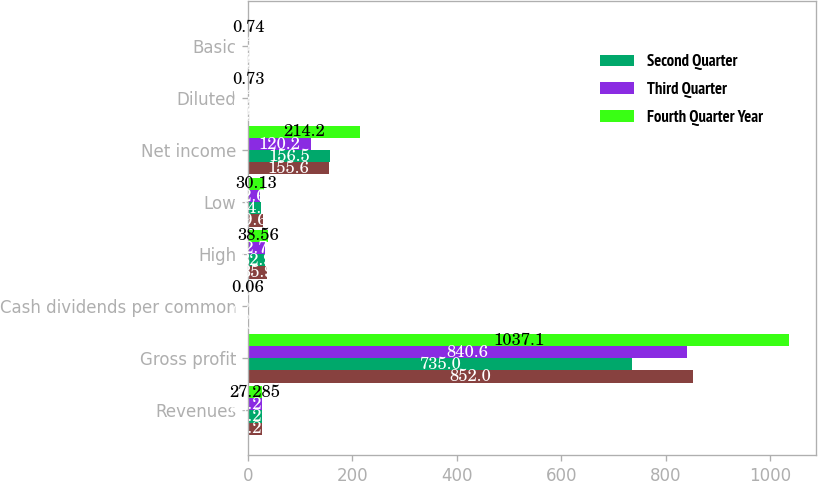Convert chart to OTSL. <chart><loc_0><loc_0><loc_500><loc_500><stacked_bar_chart><ecel><fcel>Revenues<fcel>Gross profit<fcel>Cash dividends per common<fcel>High<fcel>Low<fcel>Net income<fcel>Diluted<fcel>Basic<nl><fcel>nan<fcel>27.285<fcel>852<fcel>0.06<fcel>35.9<fcel>29.67<fcel>155.6<fcel>0.53<fcel>0.54<nl><fcel>Second Quarter<fcel>27.285<fcel>735<fcel>0.06<fcel>32.9<fcel>24.9<fcel>156.5<fcel>0.53<fcel>0.54<nl><fcel>Third Quarter<fcel>27.285<fcel>840.6<fcel>0.06<fcel>32.72<fcel>22.61<fcel>120.2<fcel>0.41<fcel>0.41<nl><fcel>Fourth Quarter Year<fcel>27.285<fcel>1037.1<fcel>0.06<fcel>38.56<fcel>30.13<fcel>214.2<fcel>0.73<fcel>0.74<nl></chart> 